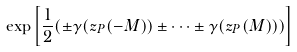<formula> <loc_0><loc_0><loc_500><loc_500>\exp \left [ \frac { 1 } { 2 } ( \pm \gamma ( z _ { P } ( - M ) ) \pm \cdots \pm \gamma ( z _ { P } ( M ) ) ) \right ]</formula> 